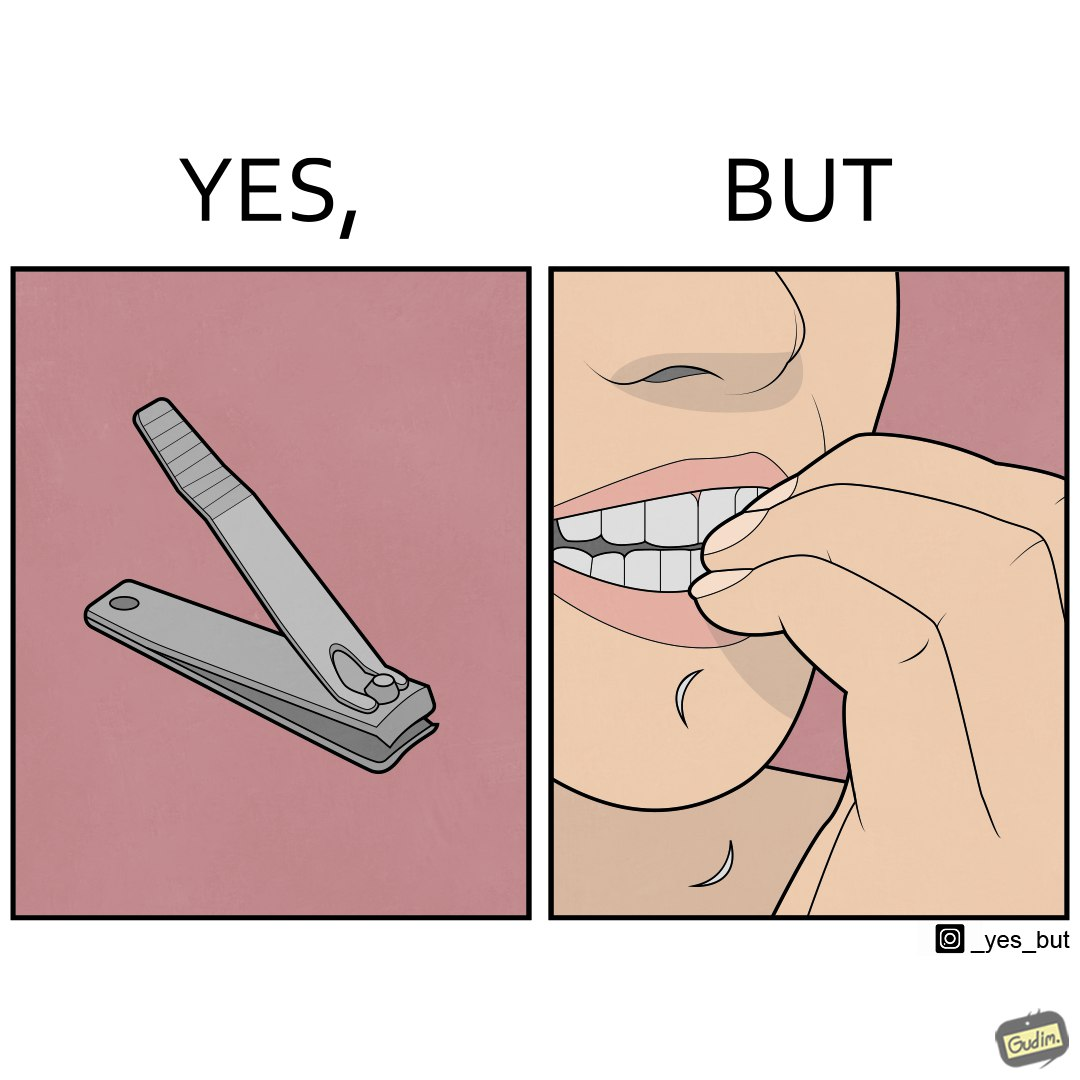Would you classify this image as satirical? Yes, this image is satirical. 